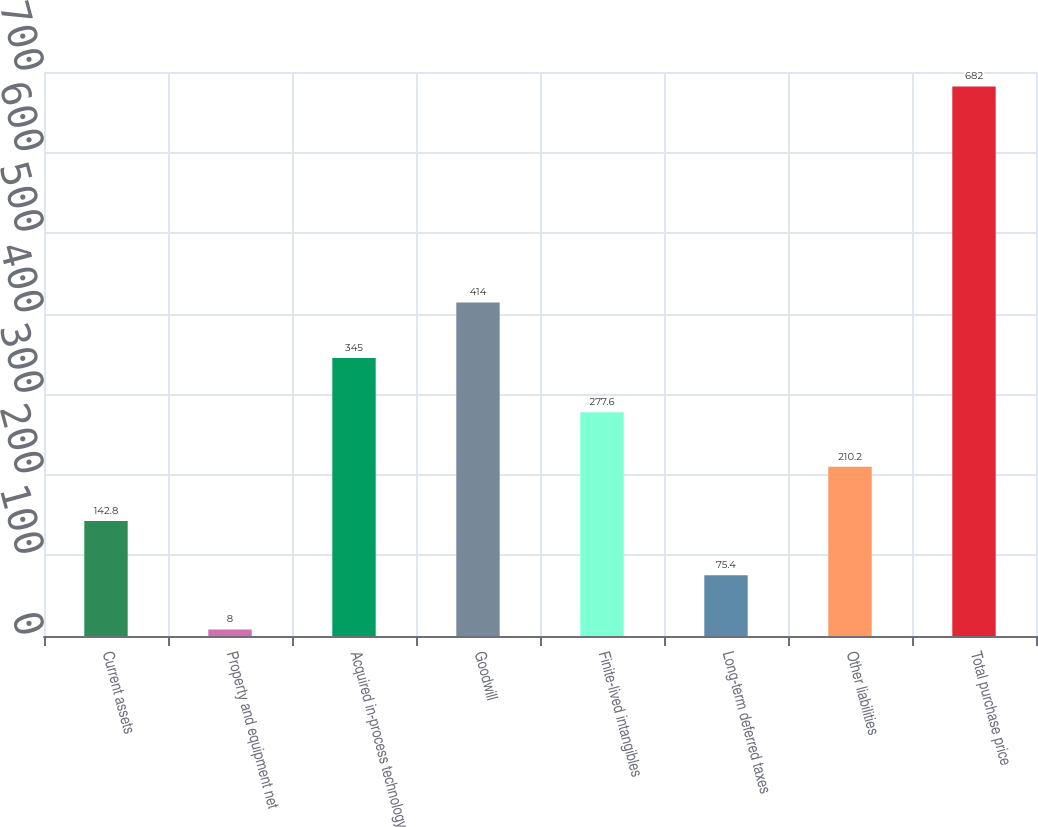Convert chart to OTSL. <chart><loc_0><loc_0><loc_500><loc_500><bar_chart><fcel>Current assets<fcel>Property and equipment net<fcel>Acquired in-process technology<fcel>Goodwill<fcel>Finite-lived intangibles<fcel>Long-term deferred taxes<fcel>Other liabilities<fcel>Total purchase price<nl><fcel>142.8<fcel>8<fcel>345<fcel>414<fcel>277.6<fcel>75.4<fcel>210.2<fcel>682<nl></chart> 